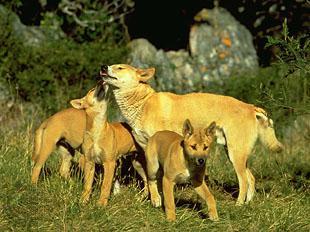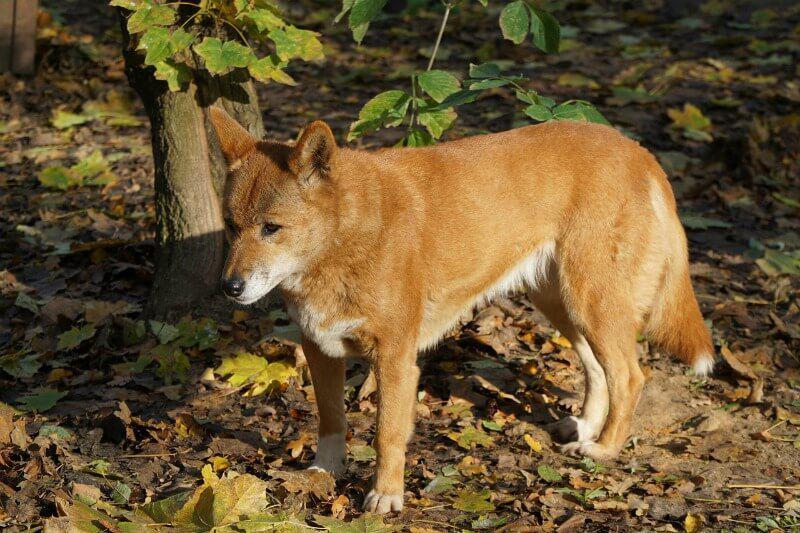The first image is the image on the left, the second image is the image on the right. Assess this claim about the two images: "There is at most 2 dingoes.". Correct or not? Answer yes or no. No. The first image is the image on the left, the second image is the image on the right. Given the left and right images, does the statement "One dog is touching another dogs chin with its head." hold true? Answer yes or no. Yes. 